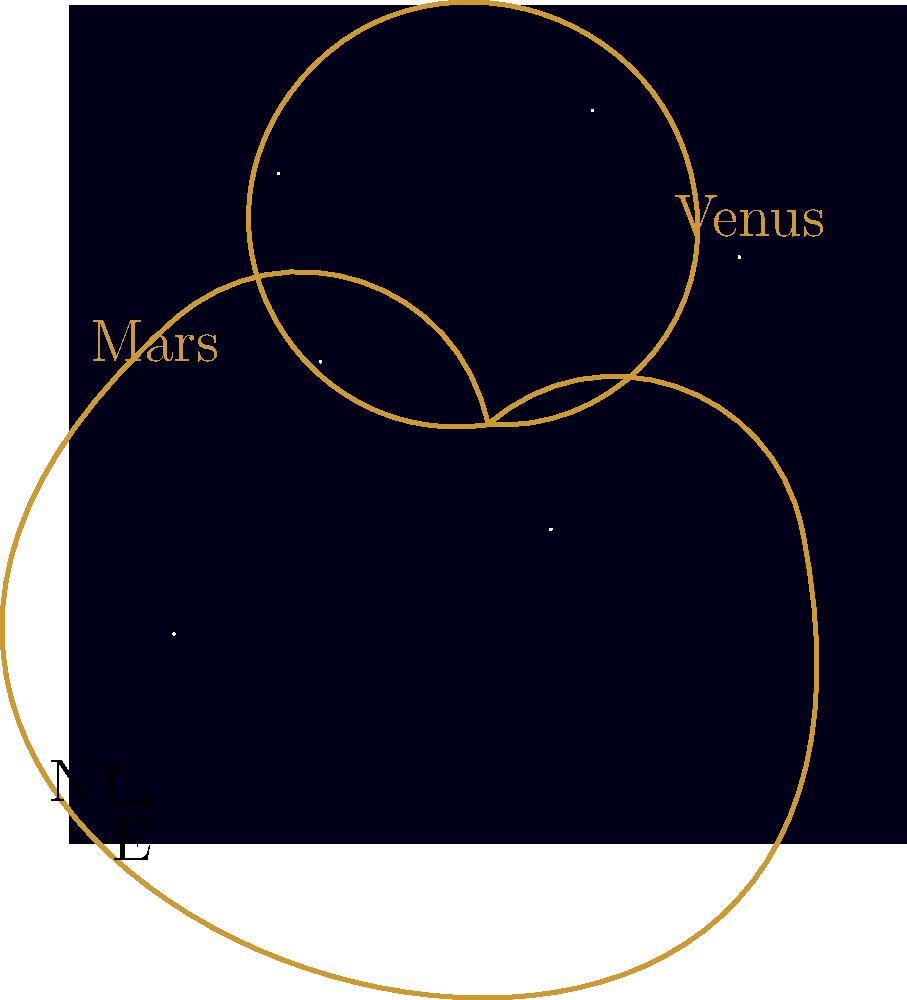While enjoying a stargazing evening on your luxury yacht in the Mediterranean, you notice the peculiar paths of Venus and Mars in the night sky over several months. What astronomical phenomenon best explains the apparent retrograde motion of these planets, as illustrated in the diagram? To understand the apparent retrograde motion of planets, let's break it down step-by-step:

1. Earth's orbit: Our planet orbits the Sun in an approximately circular path.

2. Other planets' orbits: Venus (inner planet) and Mars (outer planet) also orbit the Sun, but at different distances and speeds.

3. Relative motion: The apparent motion of planets in our night sky is due to the combination of Earth's motion and the planet's motion around the Sun.

4. Normal prograde motion: Most of the time, planets appear to move from west to east against the background of stars.

5. Retrograde motion: Occasionally, planets seem to reverse direction and move from east to west for a short period.

6. Cause of retrograde motion:
   a) For outer planets like Mars: Earth "overtakes" Mars in its orbit, causing Mars to appear to move backward.
   b) For inner planets like Venus: Venus moves faster than Earth and "laps" us, creating the illusion of backward motion.

7. Loops in the sky: This combination of motions creates the loop-like paths seen in the diagram.

8. Heliocentric model: This phenomenon is easily explained by the Sun-centered model of the solar system proposed by Copernicus and confirmed by later astronomers.

The apparent retrograde motion is thus a result of our changing viewing angle as both Earth and the observed planets orbit the Sun at different speeds and distances.
Answer: Relative orbital motion of Earth and planets around the Sun 